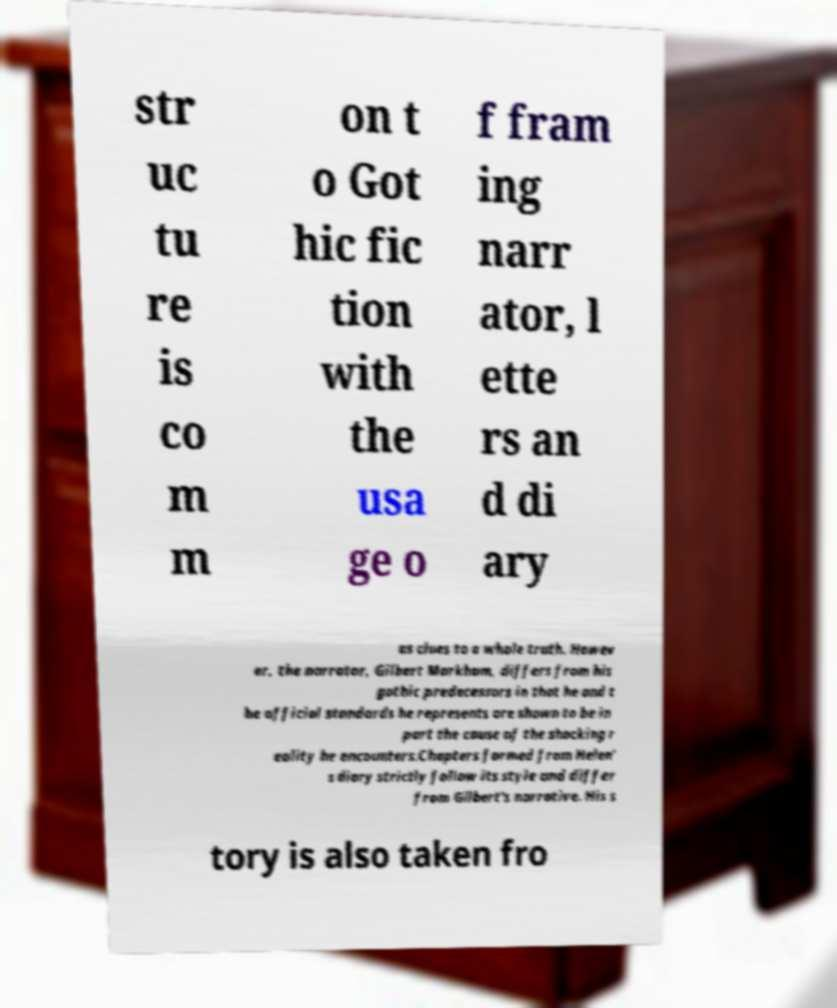Can you read and provide the text displayed in the image?This photo seems to have some interesting text. Can you extract and type it out for me? str uc tu re is co m m on t o Got hic fic tion with the usa ge o f fram ing narr ator, l ette rs an d di ary as clues to a whole truth. Howev er, the narrator, Gilbert Markham, differs from his gothic predecessors in that he and t he official standards he represents are shown to be in part the cause of the shocking r eality he encounters.Chapters formed from Helen' s diary strictly follow its style and differ from Gilbert's narrative. His s tory is also taken fro 